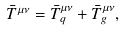Convert formula to latex. <formula><loc_0><loc_0><loc_500><loc_500>\bar { T } ^ { \mu \nu } = \bar { T } _ { q } ^ { \mu \nu } + \bar { T } _ { g } ^ { \mu \nu } ,</formula> 